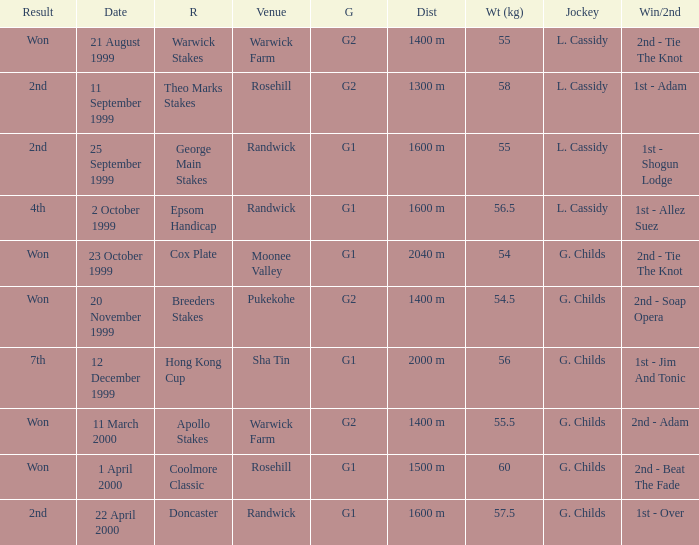How man teams had a total weight of 57.5? 1.0. 